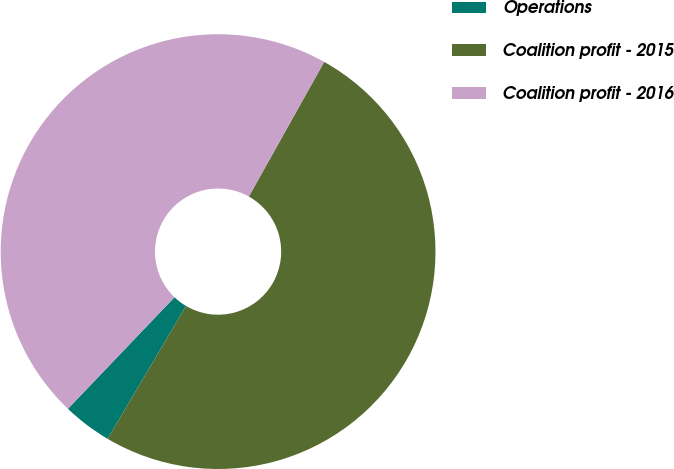Convert chart to OTSL. <chart><loc_0><loc_0><loc_500><loc_500><pie_chart><fcel>Operations<fcel>Coalition profit - 2015<fcel>Coalition profit - 2016<nl><fcel>3.65%<fcel>50.37%<fcel>45.98%<nl></chart> 